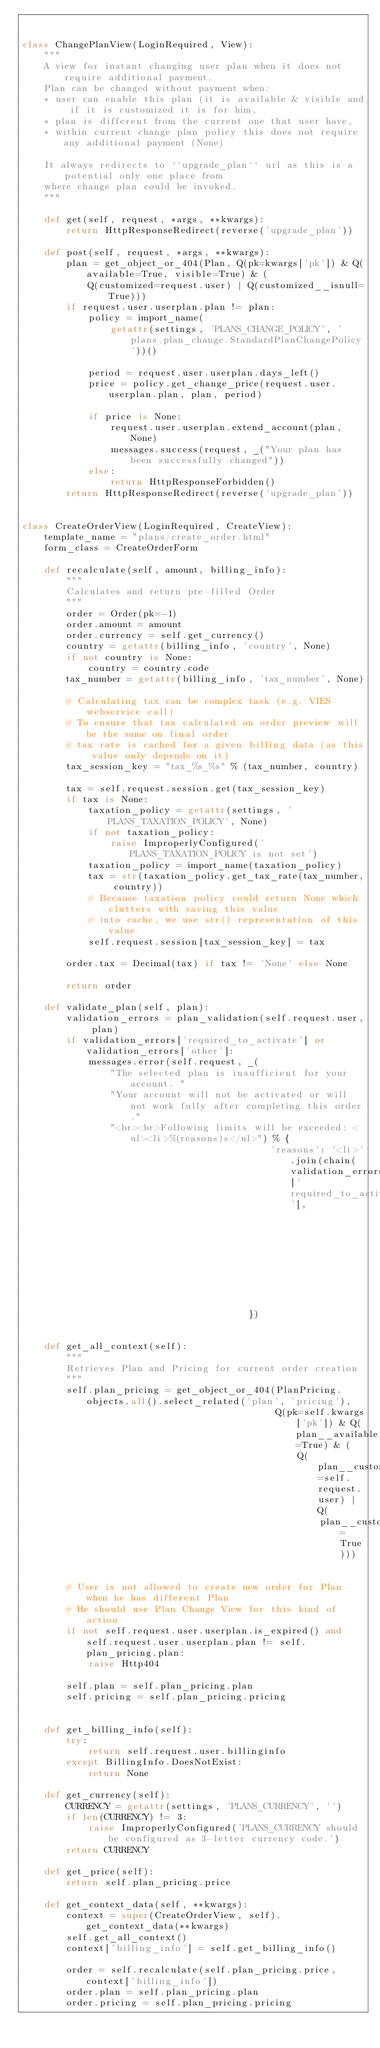Convert code to text. <code><loc_0><loc_0><loc_500><loc_500><_Python_>

class ChangePlanView(LoginRequired, View):
    """
    A view for instant changing user plan when it does not require additional payment.
    Plan can be changed without payment when:
    * user can enable this plan (it is available & visible and if it is customized it is for him,
    * plan is different from the current one that user have,
    * within current change plan policy this does not require any additional payment (None)

    It always redirects to ``upgrade_plan`` url as this is a potential only one place from
    where change plan could be invoked.
    """

    def get(self, request, *args, **kwargs):
        return HttpResponseRedirect(reverse('upgrade_plan'))

    def post(self, request, *args, **kwargs):
        plan = get_object_or_404(Plan, Q(pk=kwargs['pk']) & Q(available=True, visible=True) & (
            Q(customized=request.user) | Q(customized__isnull=True)))
        if request.user.userplan.plan != plan:
            policy = import_name(
                getattr(settings, 'PLANS_CHANGE_POLICY', 'plans.plan_change.StandardPlanChangePolicy'))()

            period = request.user.userplan.days_left()
            price = policy.get_change_price(request.user.userplan.plan, plan, period)

            if price is None:
                request.user.userplan.extend_account(plan, None)
                messages.success(request, _("Your plan has been successfully changed"))
            else:
                return HttpResponseForbidden()
        return HttpResponseRedirect(reverse('upgrade_plan'))


class CreateOrderView(LoginRequired, CreateView):
    template_name = "plans/create_order.html"
    form_class = CreateOrderForm

    def recalculate(self, amount, billing_info):
        """
        Calculates and return pre-filled Order
        """
        order = Order(pk=-1)
        order.amount = amount
        order.currency = self.get_currency()
        country = getattr(billing_info, 'country', None)
        if not country is None:
            country = country.code
        tax_number = getattr(billing_info, 'tax_number', None)

        # Calculating tax can be complex task (e.g. VIES webservice call)
        # To ensure that tax calculated on order preview will be the same on final order
        # tax rate is cached for a given billing data (as this value only depends on it)
        tax_session_key = "tax_%s_%s" % (tax_number, country)

        tax = self.request.session.get(tax_session_key)
        if tax is None:
            taxation_policy = getattr(settings, 'PLANS_TAXATION_POLICY', None)
            if not taxation_policy:
                raise ImproperlyConfigured('PLANS_TAXATION_POLICY is not set')
            taxation_policy = import_name(taxation_policy)
            tax = str(taxation_policy.get_tax_rate(tax_number, country))
            # Because taxation policy could return None which clutters with saving this value
            # into cache, we use str() representation of this value
            self.request.session[tax_session_key] = tax

        order.tax = Decimal(tax) if tax != 'None' else None

        return order

    def validate_plan(self, plan):
        validation_errors = plan_validation(self.request.user, plan)
        if validation_errors['required_to_activate'] or validation_errors['other']:
            messages.error(self.request, _(
                "The selected plan is insufficient for your account. "
                "Your account will not be activated or will not work fully after completing this order."
                "<br><br>Following limits will be exceeded: <ul><li>%(reasons)s</ul>") % {
                                             'reasons': '<li>'.join(chain(validation_errors['required_to_activate'],
                                                                          validation_errors['other'])),
                                         })


    def get_all_context(self):
        """
        Retrieves Plan and Pricing for current order creation
        """
        self.plan_pricing = get_object_or_404(PlanPricing.objects.all().select_related('plan', 'pricing'),
                                              Q(pk=self.kwargs['pk']) & Q(plan__available=True) & (
                                                  Q(plan__customized=self.request.user) | Q(
                                                      plan__customized__isnull=True)))


        # User is not allowed to create new order for Plan when he has different Plan
        # He should use Plan Change View for this kind of action
        if not self.request.user.userplan.is_expired() and self.request.user.userplan.plan != self.plan_pricing.plan:
            raise Http404

        self.plan = self.plan_pricing.plan
        self.pricing = self.plan_pricing.pricing


    def get_billing_info(self):
        try:
            return self.request.user.billinginfo
        except BillingInfo.DoesNotExist:
            return None

    def get_currency(self):
        CURRENCY = getattr(settings, 'PLANS_CURRENCY', '')
        if len(CURRENCY) != 3:
            raise ImproperlyConfigured('PLANS_CURRENCY should be configured as 3-letter currency code.')
        return CURRENCY

    def get_price(self):
        return self.plan_pricing.price

    def get_context_data(self, **kwargs):
        context = super(CreateOrderView, self).get_context_data(**kwargs)
        self.get_all_context()
        context['billing_info'] = self.get_billing_info()

        order = self.recalculate(self.plan_pricing.price, context['billing_info'])
        order.plan = self.plan_pricing.plan
        order.pricing = self.plan_pricing.pricing</code> 